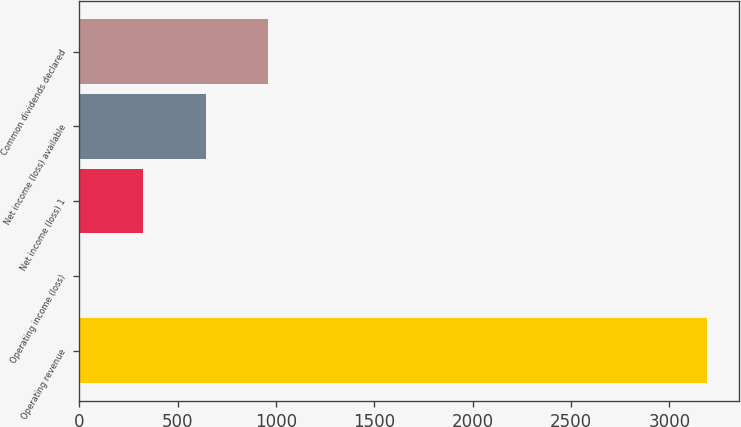<chart> <loc_0><loc_0><loc_500><loc_500><bar_chart><fcel>Operating revenue<fcel>Operating income (loss)<fcel>Net income (loss) 1<fcel>Net income (loss) available<fcel>Common dividends declared<nl><fcel>3193<fcel>4<fcel>322.9<fcel>641.8<fcel>960.7<nl></chart> 